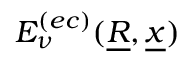Convert formula to latex. <formula><loc_0><loc_0><loc_500><loc_500>E _ { \nu } ^ { ( e c ) } ( \underline { R } , \underline { x } )</formula> 